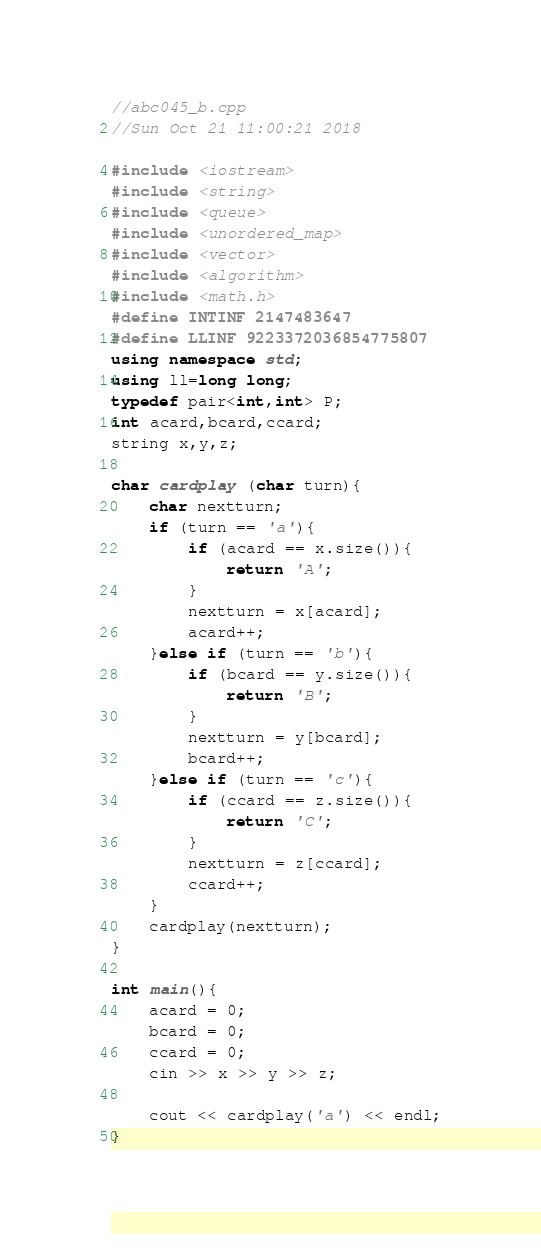<code> <loc_0><loc_0><loc_500><loc_500><_C++_>//abc045_b.cpp
//Sun Oct 21 11:00:21 2018

#include <iostream>
#include <string>
#include <queue>
#include <unordered_map>
#include <vector>
#include <algorithm>
#include <math.h>
#define INTINF 2147483647
#define LLINF 9223372036854775807
using namespace std;
using ll=long long;
typedef pair<int,int> P;
int acard,bcard,ccard;
string x,y,z;

char cardplay (char turn){
	char nextturn;
	if (turn == 'a'){
		if (acard == x.size()){
			return 'A';
		}
		nextturn = x[acard];
		acard++;
	}else if (turn == 'b'){
		if (bcard == y.size()){
			return 'B';
		}
		nextturn = y[bcard];
		bcard++;
	}else if (turn == 'c'){
		if (ccard == z.size()){
			return 'C';
		}
		nextturn = z[ccard];
		ccard++;
	}
	cardplay(nextturn);
}

int main(){
	acard = 0;
	bcard = 0;
	ccard = 0;
	cin >> x >> y >> z;

	cout << cardplay('a') << endl;
}</code> 